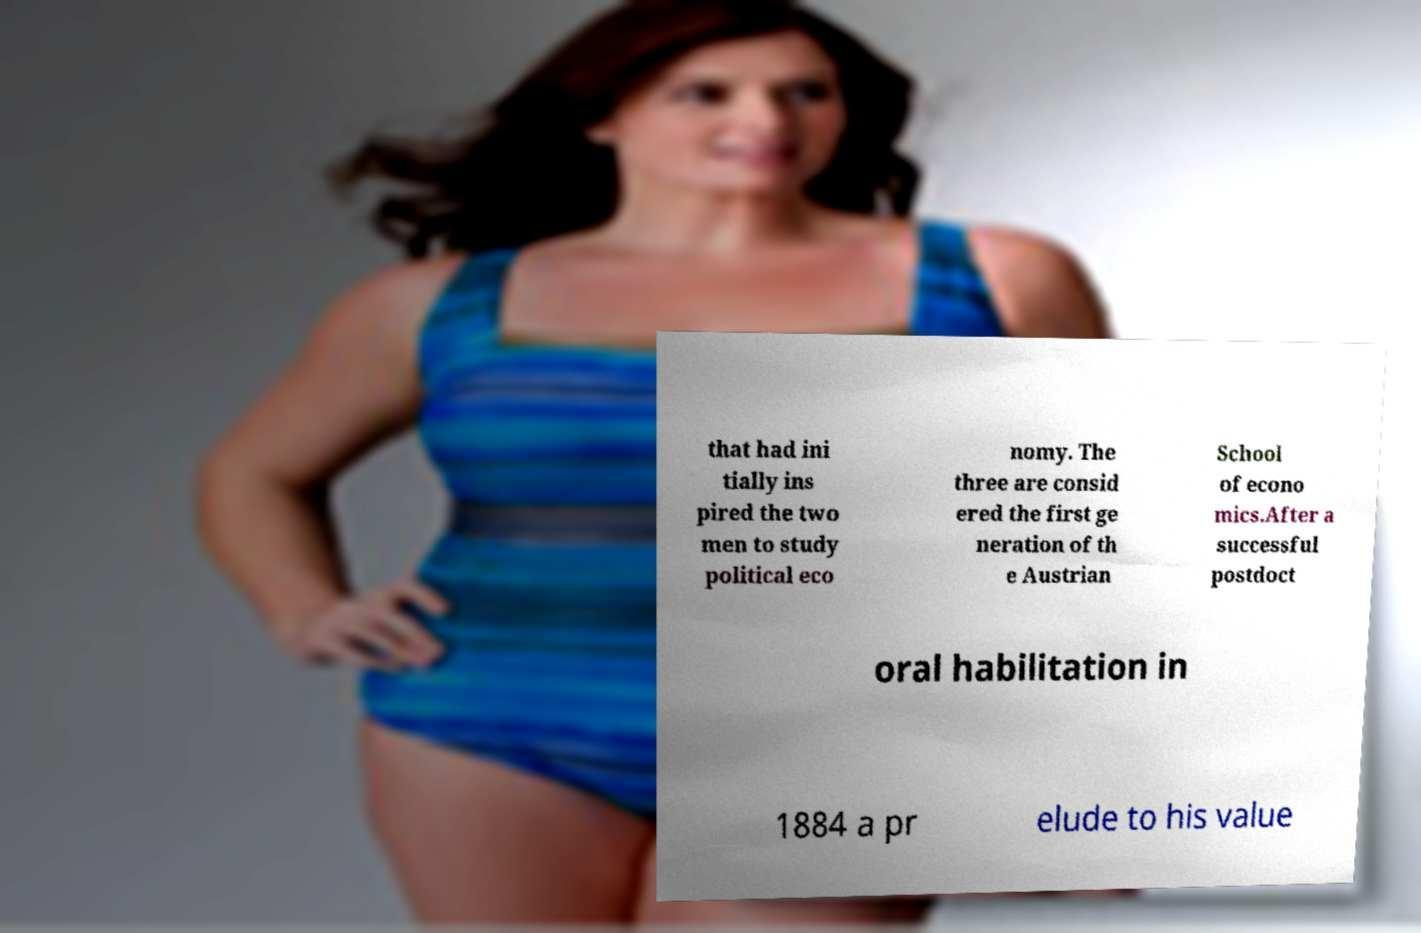Please read and relay the text visible in this image. What does it say? that had ini tially ins pired the two men to study political eco nomy. The three are consid ered the first ge neration of th e Austrian School of econo mics.After a successful postdoct oral habilitation in 1884 a pr elude to his value 